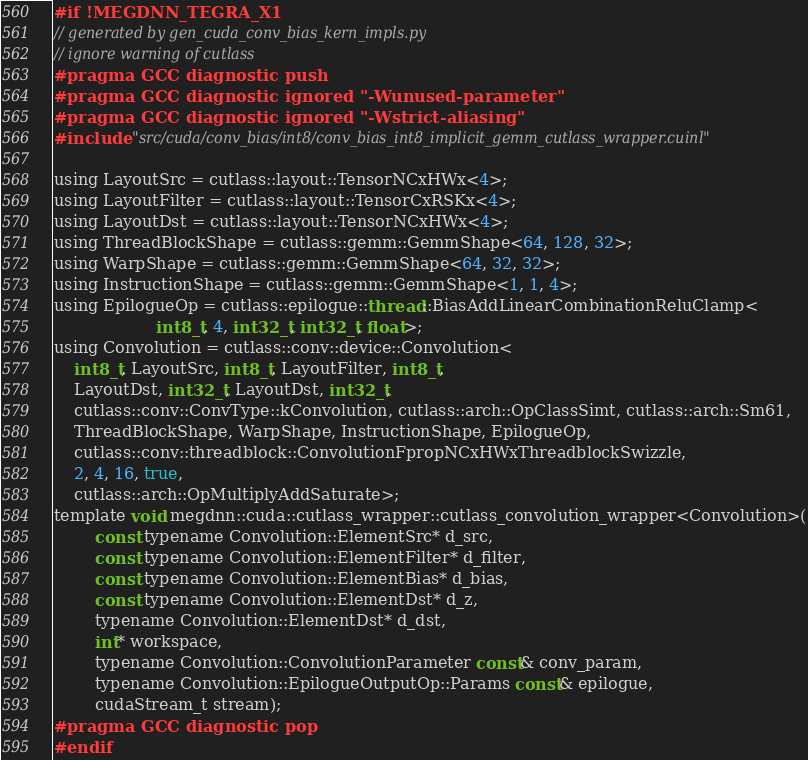Convert code to text. <code><loc_0><loc_0><loc_500><loc_500><_Cuda_>#if !MEGDNN_TEGRA_X1
// generated by gen_cuda_conv_bias_kern_impls.py
// ignore warning of cutlass
#pragma GCC diagnostic push
#pragma GCC diagnostic ignored "-Wunused-parameter"
#pragma GCC diagnostic ignored "-Wstrict-aliasing"
#include "src/cuda/conv_bias/int8/conv_bias_int8_implicit_gemm_cutlass_wrapper.cuinl"

using LayoutSrc = cutlass::layout::TensorNCxHWx<4>;
using LayoutFilter = cutlass::layout::TensorCxRSKx<4>;
using LayoutDst = cutlass::layout::TensorNCxHWx<4>;
using ThreadBlockShape = cutlass::gemm::GemmShape<64, 128, 32>;
using WarpShape = cutlass::gemm::GemmShape<64, 32, 32>;
using InstructionShape = cutlass::gemm::GemmShape<1, 1, 4>;
using EpilogueOp = cutlass::epilogue::thread::BiasAddLinearCombinationReluClamp<
                    int8_t, 4, int32_t, int32_t, float>;
using Convolution = cutlass::conv::device::Convolution<
    int8_t, LayoutSrc, int8_t, LayoutFilter, int8_t, 
    LayoutDst, int32_t, LayoutDst, int32_t, 
    cutlass::conv::ConvType::kConvolution, cutlass::arch::OpClassSimt, cutlass::arch::Sm61, 
    ThreadBlockShape, WarpShape, InstructionShape, EpilogueOp, 
    cutlass::conv::threadblock::ConvolutionFpropNCxHWxThreadblockSwizzle, 
    2, 4, 16, true, 
    cutlass::arch::OpMultiplyAddSaturate>;
template void megdnn::cuda::cutlass_wrapper::cutlass_convolution_wrapper<Convolution>(
        const typename Convolution::ElementSrc* d_src, 
        const typename Convolution::ElementFilter* d_filter, 
        const typename Convolution::ElementBias* d_bias, 
        const typename Convolution::ElementDst* d_z, 
        typename Convolution::ElementDst* d_dst, 
        int* workspace, 
        typename Convolution::ConvolutionParameter const& conv_param, 
        typename Convolution::EpilogueOutputOp::Params const& epilogue, 
        cudaStream_t stream);
#pragma GCC diagnostic pop
#endif
</code> 